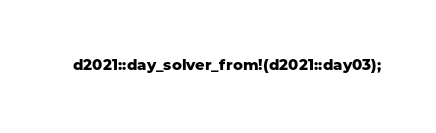<code> <loc_0><loc_0><loc_500><loc_500><_Rust_>d2021::day_solver_from!(d2021::day03);
</code> 